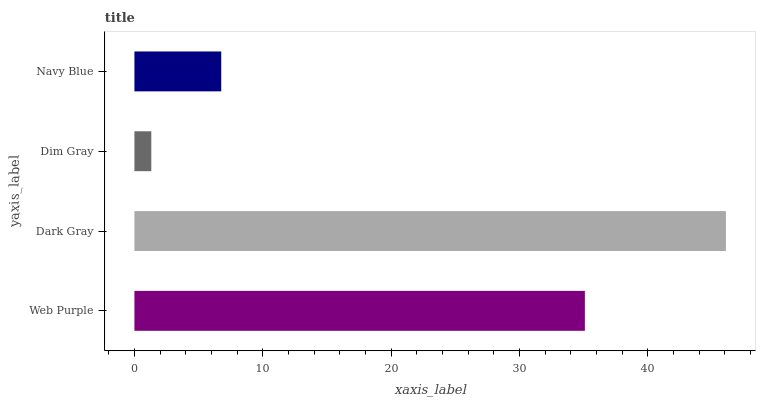Is Dim Gray the minimum?
Answer yes or no. Yes. Is Dark Gray the maximum?
Answer yes or no. Yes. Is Dark Gray the minimum?
Answer yes or no. No. Is Dim Gray the maximum?
Answer yes or no. No. Is Dark Gray greater than Dim Gray?
Answer yes or no. Yes. Is Dim Gray less than Dark Gray?
Answer yes or no. Yes. Is Dim Gray greater than Dark Gray?
Answer yes or no. No. Is Dark Gray less than Dim Gray?
Answer yes or no. No. Is Web Purple the high median?
Answer yes or no. Yes. Is Navy Blue the low median?
Answer yes or no. Yes. Is Dark Gray the high median?
Answer yes or no. No. Is Web Purple the low median?
Answer yes or no. No. 